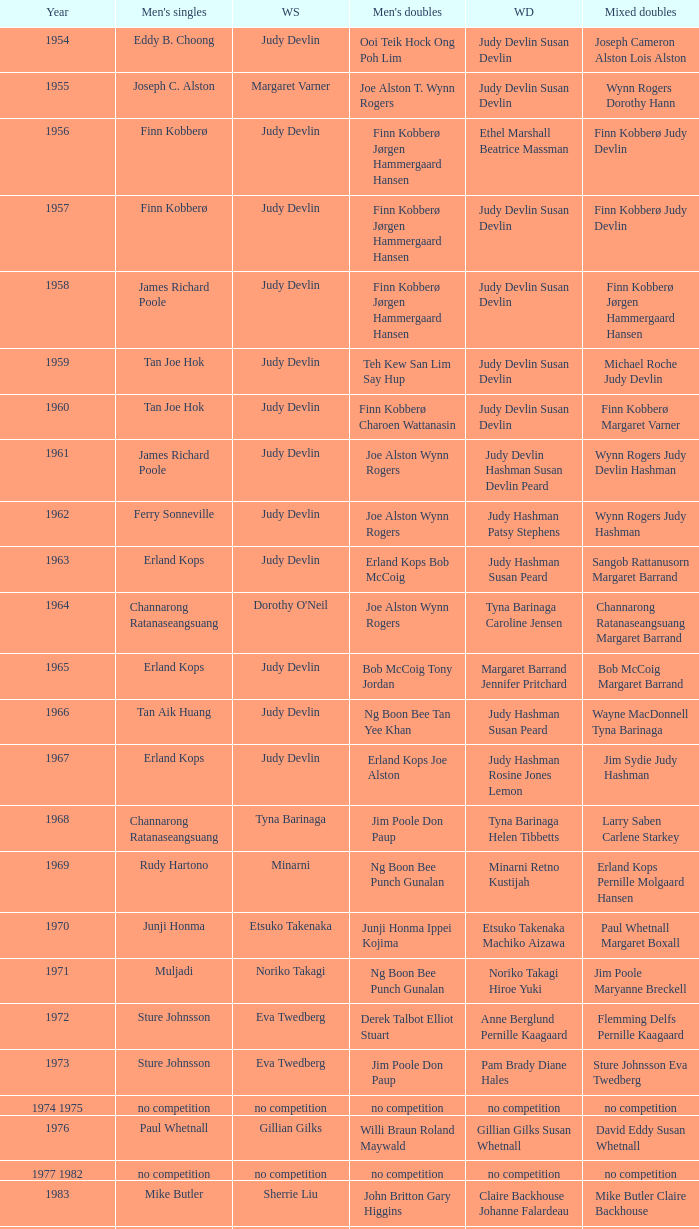Who was the women's singles champion in 1984? Luo Yun. 